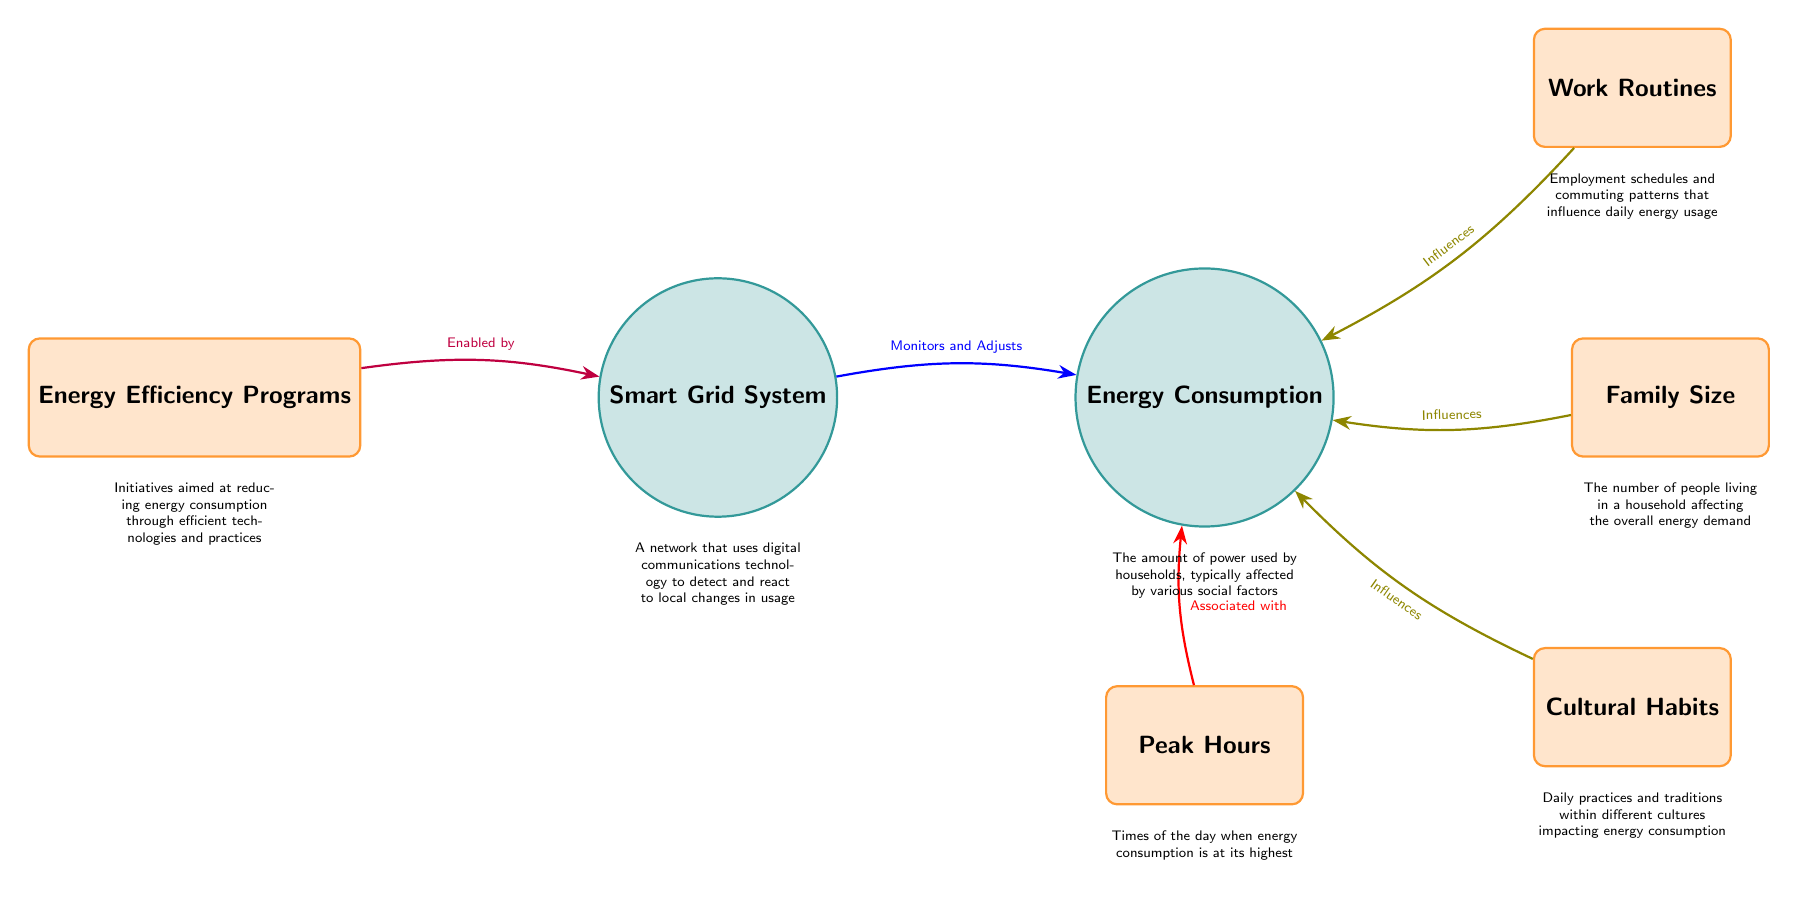What are the three social factors influencing energy consumption? The diagram shows three social factors that influence energy consumption, which are Work Routines, Family Size, and Cultural Habits. Each factor connects with an arrow labeled "Influences" pointing to the Energy Consumption node.
Answer: Work Routines, Family Size, Cultural Habits How many nodes are present in the diagram? The diagram contains a total of six nodes: Smart Grid System, Energy Consumption, Work Routines, Family Size, Cultural Habits, and Peak Hours, along with one additional node, Energy Efficiency Programs, making the total count seven.
Answer: 7 Which factor is associated with peak hours? The diagram clearly indicates that Peak Hours is connected to Energy Consumption with an arrow labeled "Associated with," identifying it as a relevant aspect that correlates with energy use during specific times.
Answer: Peak Hours What does the Smart Grid System do? The diagram describes the Smart Grid System as a network that uses digital communications technology to detect and react to local changes in usage, represented in the description below this node.
Answer: Detect and react to local changes Which node enables the Smart Grid System? The arrow pointing from the Energy Efficiency Programs node to the Smart Grid System node is labeled "Enabled by," indicating that Energy Efficiency Programs provide the functionality necessary for the Smart Grid System to operate effectively.
Answer: Energy Efficiency Programs How does energy efficiency relate to energy consumption? The diagram shows a connection where Energy Efficiency Programs lead to the Smart Grid System, and subsequently, this system monitors and adjusts Energy Consumption, implying that efficient practices can influence consumption patterns positively.
Answer: Monitors and Adjusts 